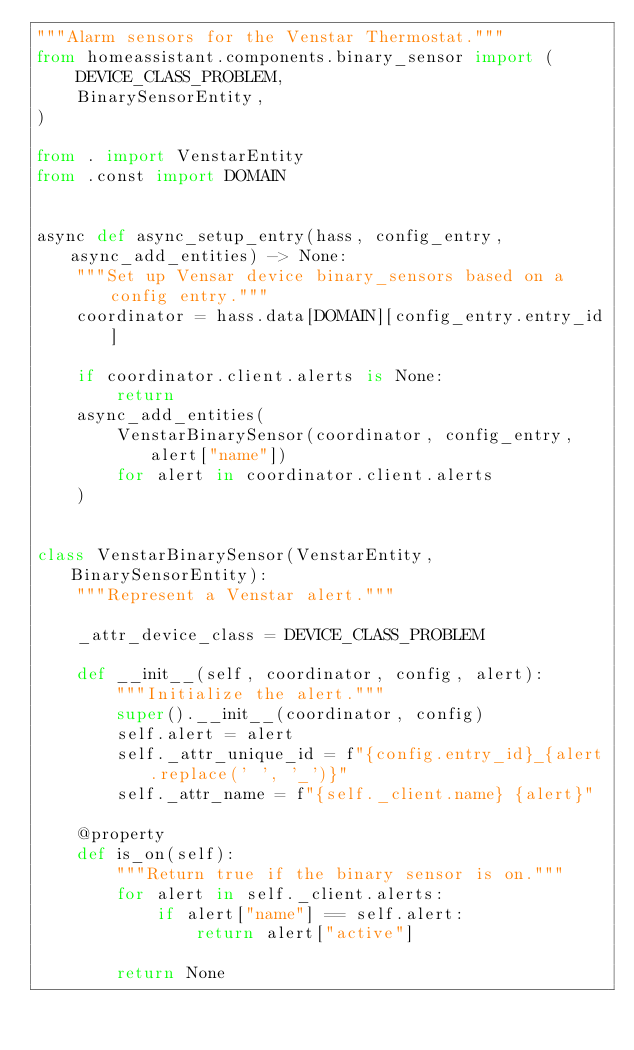<code> <loc_0><loc_0><loc_500><loc_500><_Python_>"""Alarm sensors for the Venstar Thermostat."""
from homeassistant.components.binary_sensor import (
    DEVICE_CLASS_PROBLEM,
    BinarySensorEntity,
)

from . import VenstarEntity
from .const import DOMAIN


async def async_setup_entry(hass, config_entry, async_add_entities) -> None:
    """Set up Vensar device binary_sensors based on a config entry."""
    coordinator = hass.data[DOMAIN][config_entry.entry_id]

    if coordinator.client.alerts is None:
        return
    async_add_entities(
        VenstarBinarySensor(coordinator, config_entry, alert["name"])
        for alert in coordinator.client.alerts
    )


class VenstarBinarySensor(VenstarEntity, BinarySensorEntity):
    """Represent a Venstar alert."""

    _attr_device_class = DEVICE_CLASS_PROBLEM

    def __init__(self, coordinator, config, alert):
        """Initialize the alert."""
        super().__init__(coordinator, config)
        self.alert = alert
        self._attr_unique_id = f"{config.entry_id}_{alert.replace(' ', '_')}"
        self._attr_name = f"{self._client.name} {alert}"

    @property
    def is_on(self):
        """Return true if the binary sensor is on."""
        for alert in self._client.alerts:
            if alert["name"] == self.alert:
                return alert["active"]

        return None
</code> 